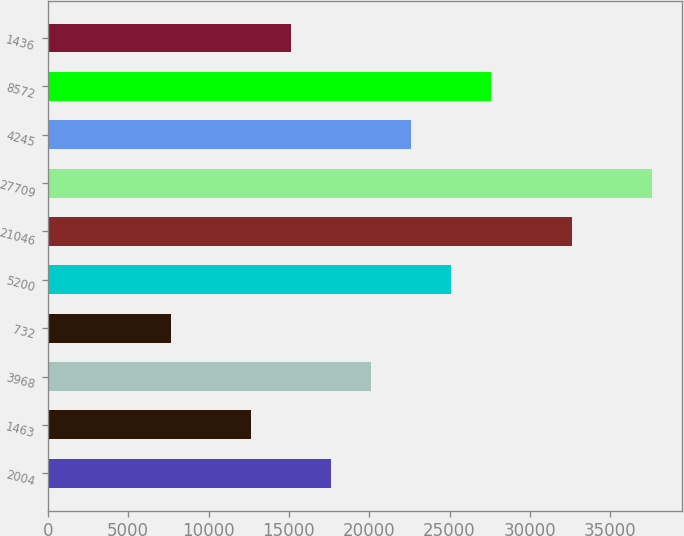Convert chart. <chart><loc_0><loc_0><loc_500><loc_500><bar_chart><fcel>2004<fcel>1463<fcel>3968<fcel>732<fcel>5200<fcel>21046<fcel>27709<fcel>4245<fcel>8572<fcel>1436<nl><fcel>17636.3<fcel>12650.5<fcel>20129.2<fcel>7664.7<fcel>25115<fcel>32593.7<fcel>37579.5<fcel>22622.1<fcel>27607.9<fcel>15143.4<nl></chart> 